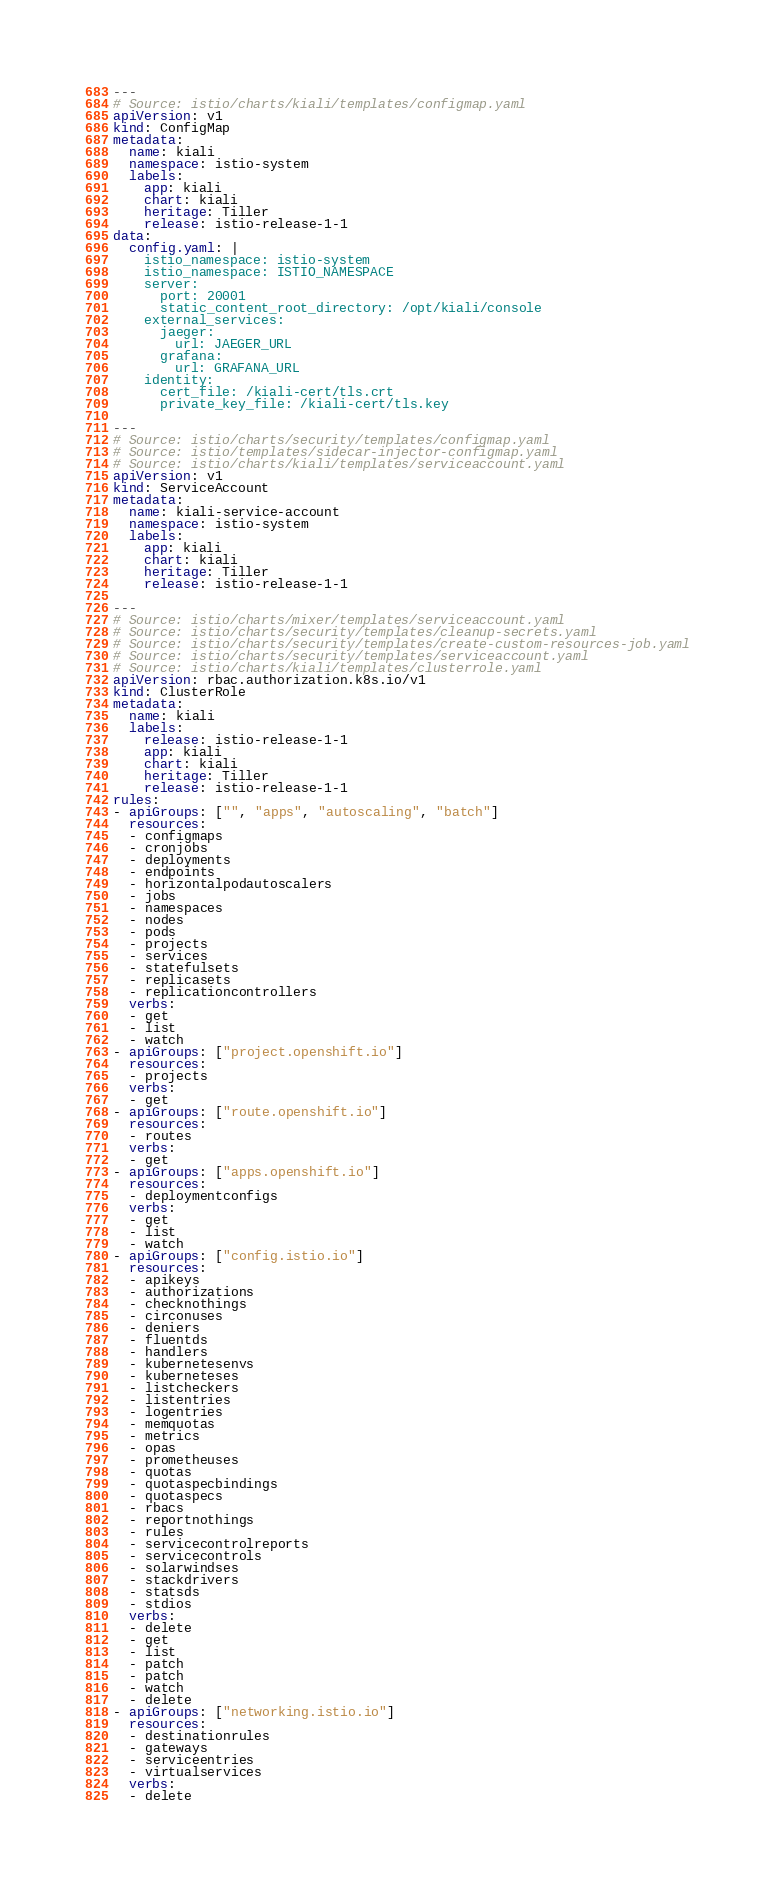Convert code to text. <code><loc_0><loc_0><loc_500><loc_500><_YAML_>---
# Source: istio/charts/kiali/templates/configmap.yaml
apiVersion: v1
kind: ConfigMap
metadata:
  name: kiali
  namespace: istio-system
  labels:
    app: kiali
    chart: kiali
    heritage: Tiller
    release: istio-release-1-1
data:
  config.yaml: |
    istio_namespace: istio-system
    istio_namespace: ISTIO_NAMESPACE
    server:
      port: 20001
      static_content_root_directory: /opt/kiali/console
    external_services:
      jaeger:
        url: JAEGER_URL
      grafana:
        url: GRAFANA_URL
    identity:
      cert_file: /kiali-cert/tls.crt
      private_key_file: /kiali-cert/tls.key

---
# Source: istio/charts/security/templates/configmap.yaml
# Source: istio/templates/sidecar-injector-configmap.yaml
# Source: istio/charts/kiali/templates/serviceaccount.yaml
apiVersion: v1
kind: ServiceAccount
metadata:
  name: kiali-service-account
  namespace: istio-system
  labels:
    app: kiali
    chart: kiali
    heritage: Tiller
    release: istio-release-1-1

---
# Source: istio/charts/mixer/templates/serviceaccount.yaml
# Source: istio/charts/security/templates/cleanup-secrets.yaml
# Source: istio/charts/security/templates/create-custom-resources-job.yaml
# Source: istio/charts/security/templates/serviceaccount.yaml
# Source: istio/charts/kiali/templates/clusterrole.yaml
apiVersion: rbac.authorization.k8s.io/v1
kind: ClusterRole
metadata:
  name: kiali
  labels:
    release: istio-release-1-1
    app: kiali
    chart: kiali
    heritage: Tiller
    release: istio-release-1-1
rules:
- apiGroups: ["", "apps", "autoscaling", "batch"]
  resources:
  - configmaps
  - cronjobs
  - deployments
  - endpoints
  - horizontalpodautoscalers
  - jobs
  - namespaces
  - nodes
  - pods
  - projects
  - services
  - statefulsets
  - replicasets
  - replicationcontrollers
  verbs:
  - get
  - list
  - watch
- apiGroups: ["project.openshift.io"]
  resources:
  - projects
  verbs:
  - get
- apiGroups: ["route.openshift.io"]
  resources:
  - routes
  verbs:
  - get
- apiGroups: ["apps.openshift.io"]
  resources:
  - deploymentconfigs
  verbs:
  - get
  - list
  - watch
- apiGroups: ["config.istio.io"]
  resources:
  - apikeys
  - authorizations
  - checknothings
  - circonuses
  - deniers
  - fluentds
  - handlers
  - kubernetesenvs
  - kuberneteses
  - listcheckers
  - listentries
  - logentries
  - memquotas
  - metrics
  - opas
  - prometheuses
  - quotas
  - quotaspecbindings
  - quotaspecs
  - rbacs
  - reportnothings
  - rules
  - servicecontrolreports
  - servicecontrols
  - solarwindses
  - stackdrivers
  - statsds
  - stdios
  verbs:
  - delete
  - get
  - list
  - patch
  - patch
  - watch
  - delete
- apiGroups: ["networking.istio.io"]
  resources:
  - destinationrules
  - gateways
  - serviceentries
  - virtualservices
  verbs:
  - delete</code> 